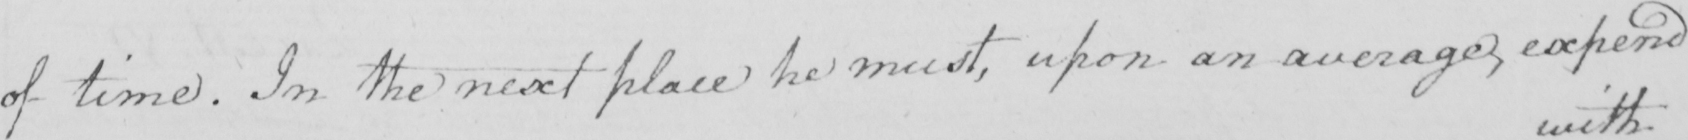Can you read and transcribe this handwriting? of time . In the next place he must , upon an average , expend 